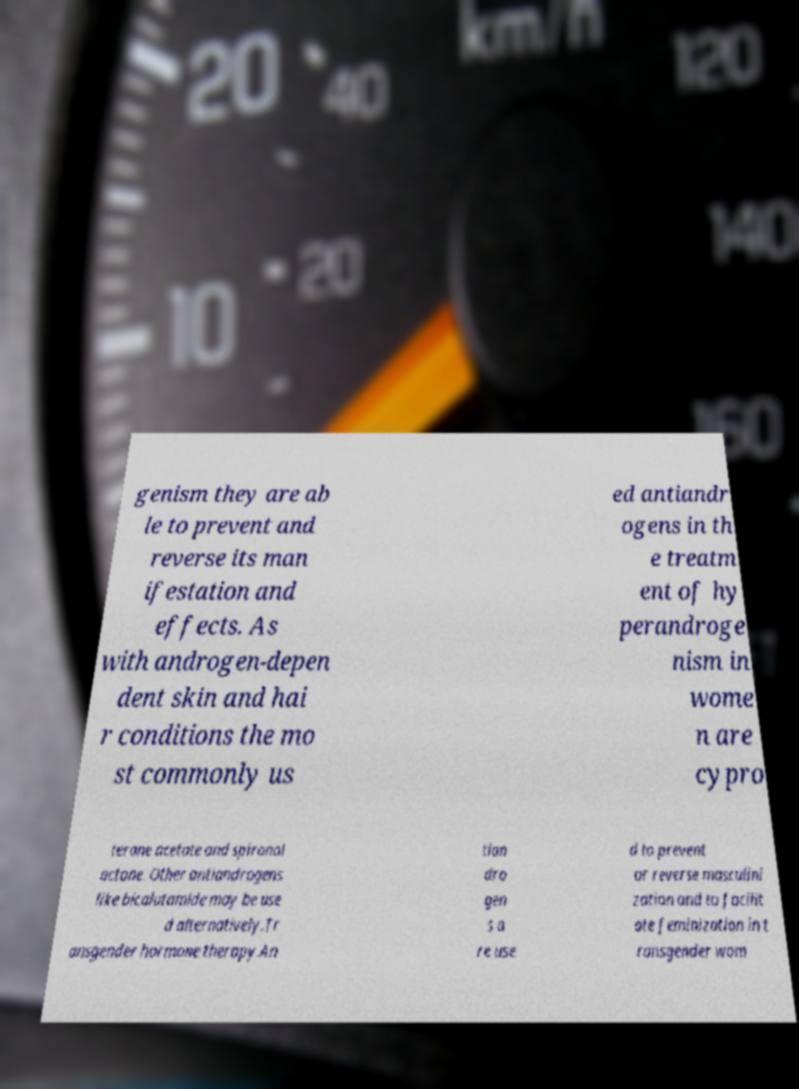What messages or text are displayed in this image? I need them in a readable, typed format. genism they are ab le to prevent and reverse its man ifestation and effects. As with androgen-depen dent skin and hai r conditions the mo st commonly us ed antiandr ogens in th e treatm ent of hy perandroge nism in wome n are cypro terone acetate and spironol actone. Other antiandrogens like bicalutamide may be use d alternatively.Tr ansgender hormone therapy.An tian dro gen s a re use d to prevent or reverse masculini zation and to facilit ate feminization in t ransgender wom 